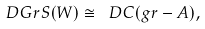<formula> <loc_0><loc_0><loc_500><loc_500>D G r S ( W ) \cong \ D C ( g r - A ) ,</formula> 